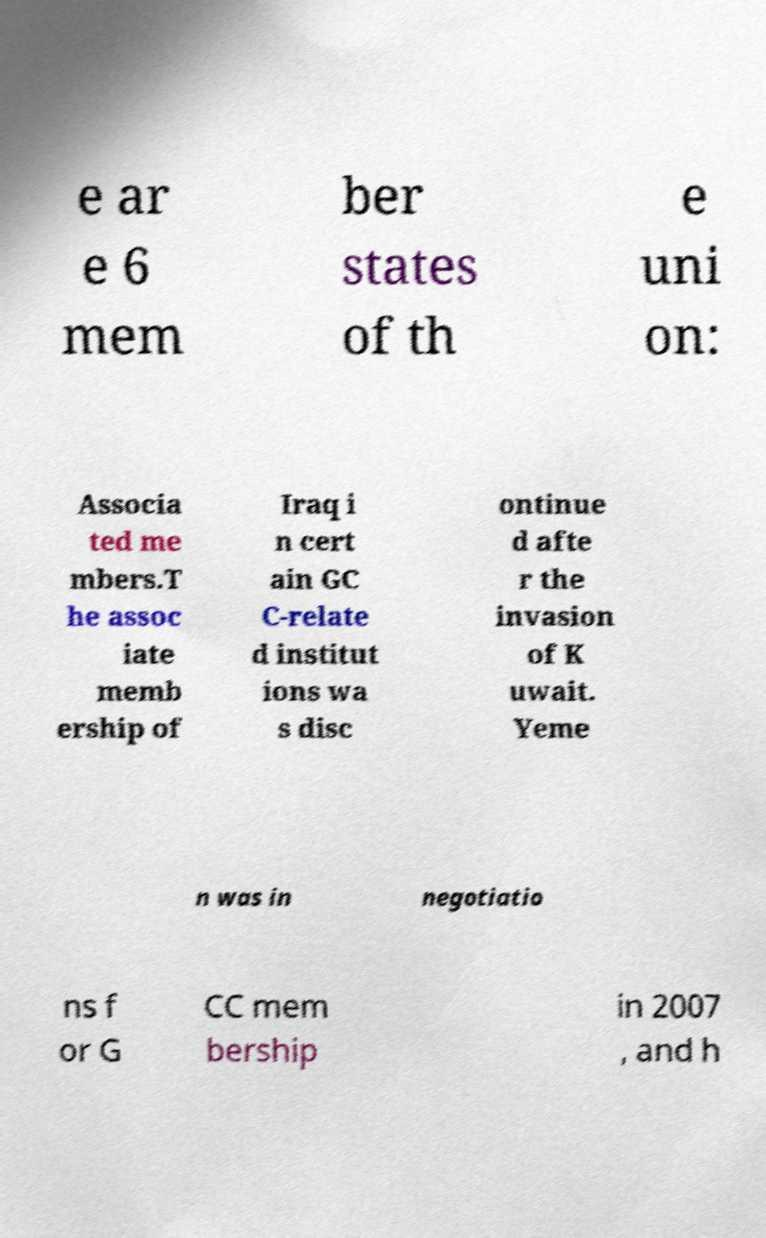Can you read and provide the text displayed in the image?This photo seems to have some interesting text. Can you extract and type it out for me? e ar e 6 mem ber states of th e uni on: Associa ted me mbers.T he assoc iate memb ership of Iraq i n cert ain GC C-relate d institut ions wa s disc ontinue d afte r the invasion of K uwait. Yeme n was in negotiatio ns f or G CC mem bership in 2007 , and h 